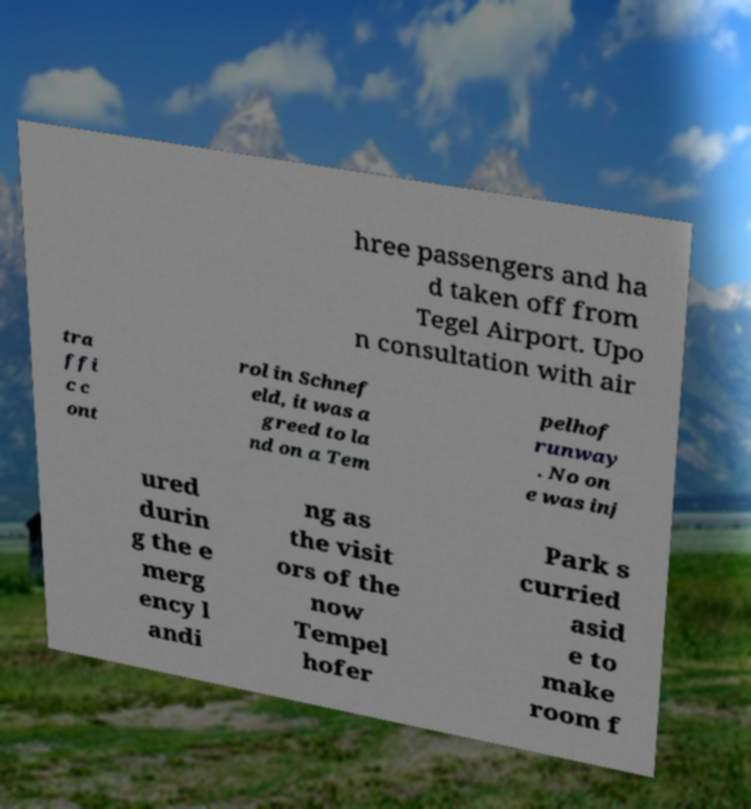Could you assist in decoding the text presented in this image and type it out clearly? hree passengers and ha d taken off from Tegel Airport. Upo n consultation with air tra ffi c c ont rol in Schnef eld, it was a greed to la nd on a Tem pelhof runway . No on e was inj ured durin g the e merg ency l andi ng as the visit ors of the now Tempel hofer Park s curried asid e to make room f 